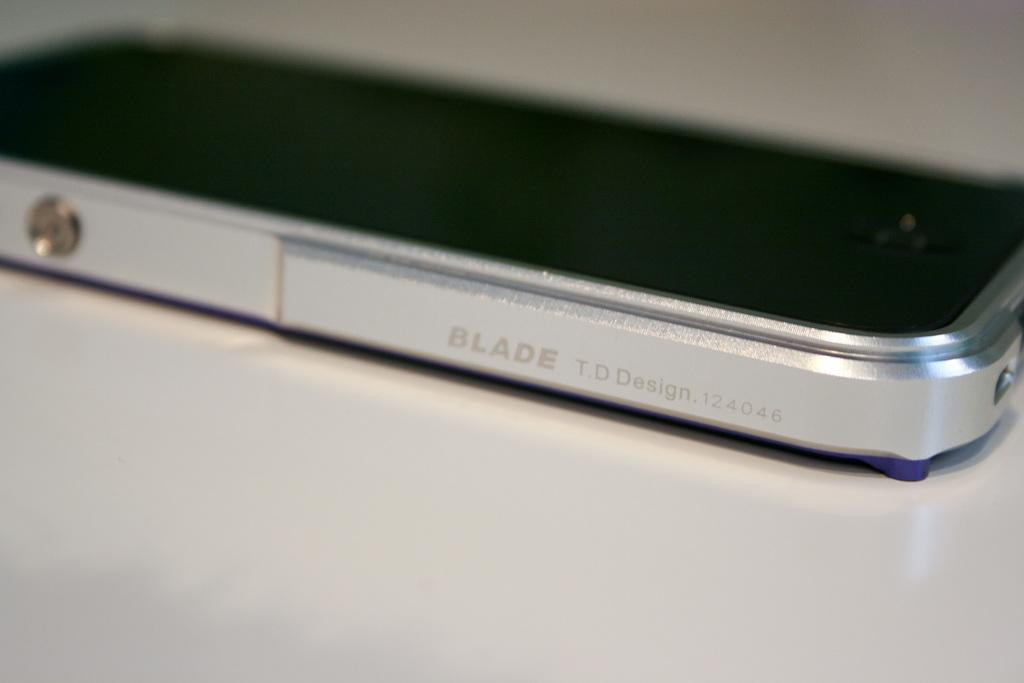<image>
Describe the image concisely. Silver and black cellphone that says BLADE Design on it. 